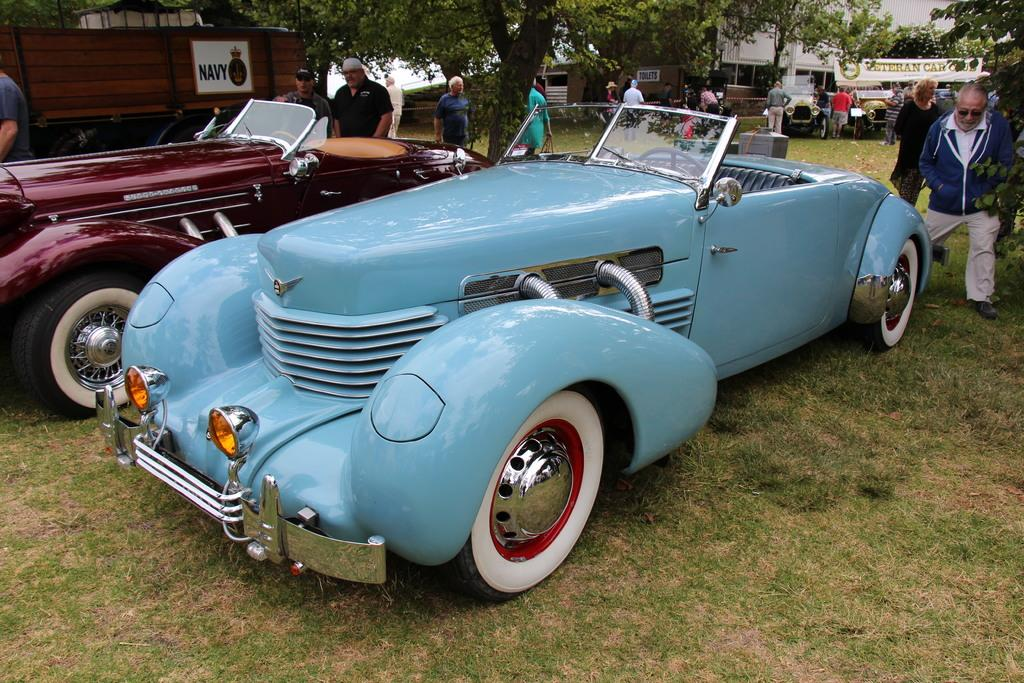What can be seen in the image that moves or transports people or goods? There are vehicles in the image that move or transport people or goods. What else is present in the image besides vehicles? There is a group of people standing in the image. What can be seen in the background of the image? There are trees and a building in the background of the image. Where are the goats sleeping in the image? There are no goats present in the image, so it is not possible to determine where they might be sleeping. 